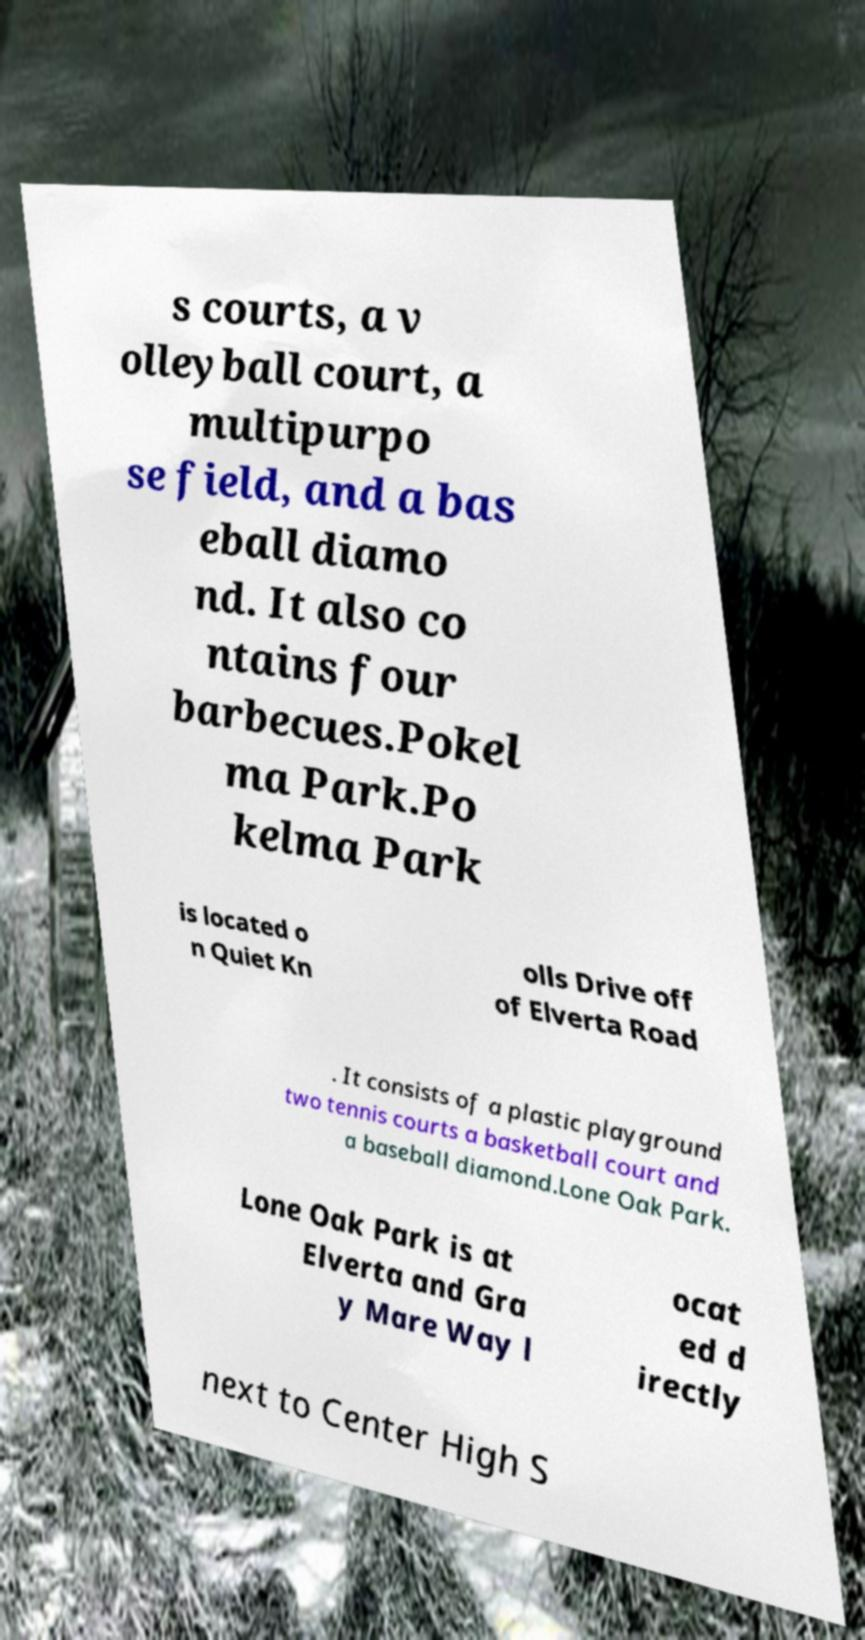For documentation purposes, I need the text within this image transcribed. Could you provide that? s courts, a v olleyball court, a multipurpo se field, and a bas eball diamo nd. It also co ntains four barbecues.Pokel ma Park.Po kelma Park is located o n Quiet Kn olls Drive off of Elverta Road . It consists of a plastic playground two tennis courts a basketball court and a baseball diamond.Lone Oak Park. Lone Oak Park is at Elverta and Gra y Mare Way l ocat ed d irectly next to Center High S 